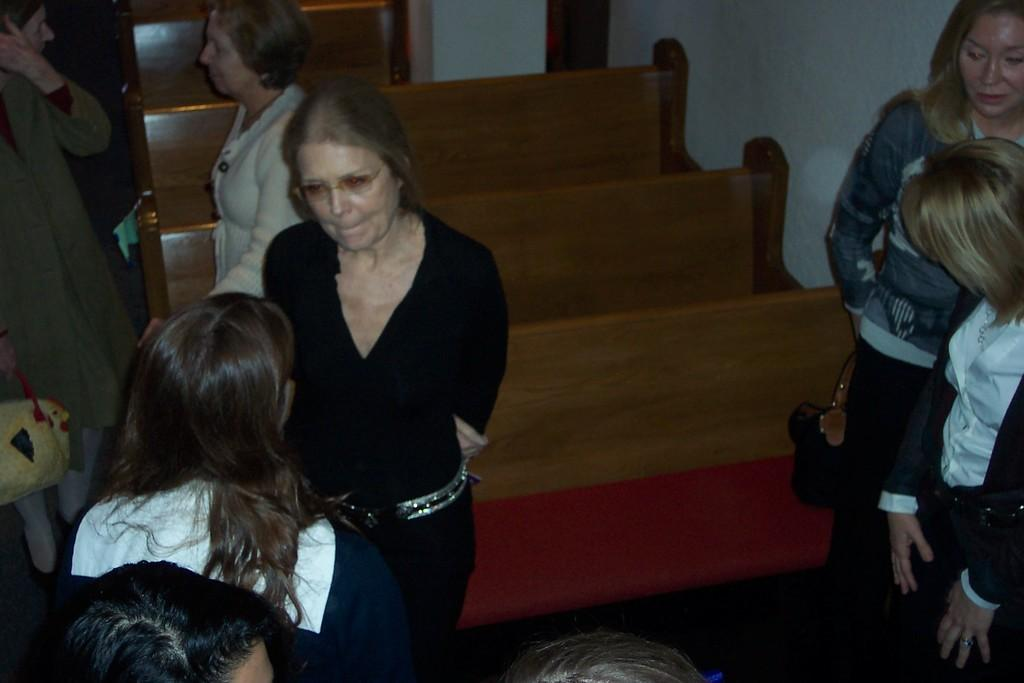What can be seen in the image? There are women standing in the image. What is visible in the background of the image? There are benches in the background of the image. Where is the wall located in the image? There is a wall visible in the top right side of the image. What word is being spoken by the women in the image? There is no indication of any spoken words in the image, so it cannot be determined which word might be spoken. 